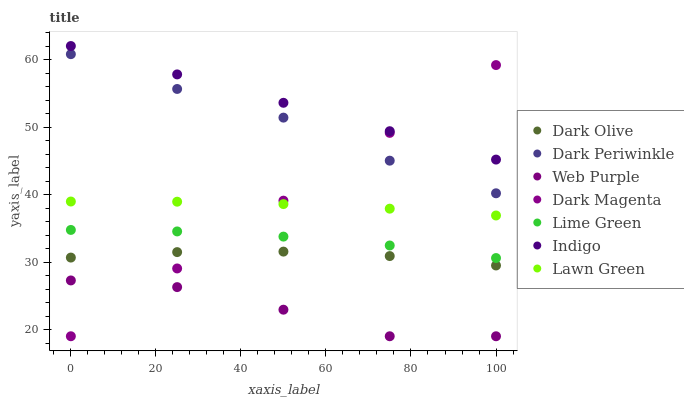Does Web Purple have the minimum area under the curve?
Answer yes or no. Yes. Does Indigo have the maximum area under the curve?
Answer yes or no. Yes. Does Dark Magenta have the minimum area under the curve?
Answer yes or no. No. Does Dark Magenta have the maximum area under the curve?
Answer yes or no. No. Is Dark Magenta the smoothest?
Answer yes or no. Yes. Is Web Purple the roughest?
Answer yes or no. Yes. Is Indigo the smoothest?
Answer yes or no. No. Is Indigo the roughest?
Answer yes or no. No. Does Dark Magenta have the lowest value?
Answer yes or no. Yes. Does Indigo have the lowest value?
Answer yes or no. No. Does Indigo have the highest value?
Answer yes or no. Yes. Does Dark Magenta have the highest value?
Answer yes or no. No. Is Web Purple less than Lime Green?
Answer yes or no. Yes. Is Indigo greater than Dark Periwinkle?
Answer yes or no. Yes. Does Dark Magenta intersect Lime Green?
Answer yes or no. Yes. Is Dark Magenta less than Lime Green?
Answer yes or no. No. Is Dark Magenta greater than Lime Green?
Answer yes or no. No. Does Web Purple intersect Lime Green?
Answer yes or no. No. 